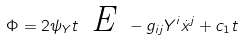Convert formula to latex. <formula><loc_0><loc_0><loc_500><loc_500>\Phi = 2 \psi _ { Y } t \emph { E } - g _ { i j } Y ^ { i } \dot { x } ^ { j } + c _ { 1 } t</formula> 